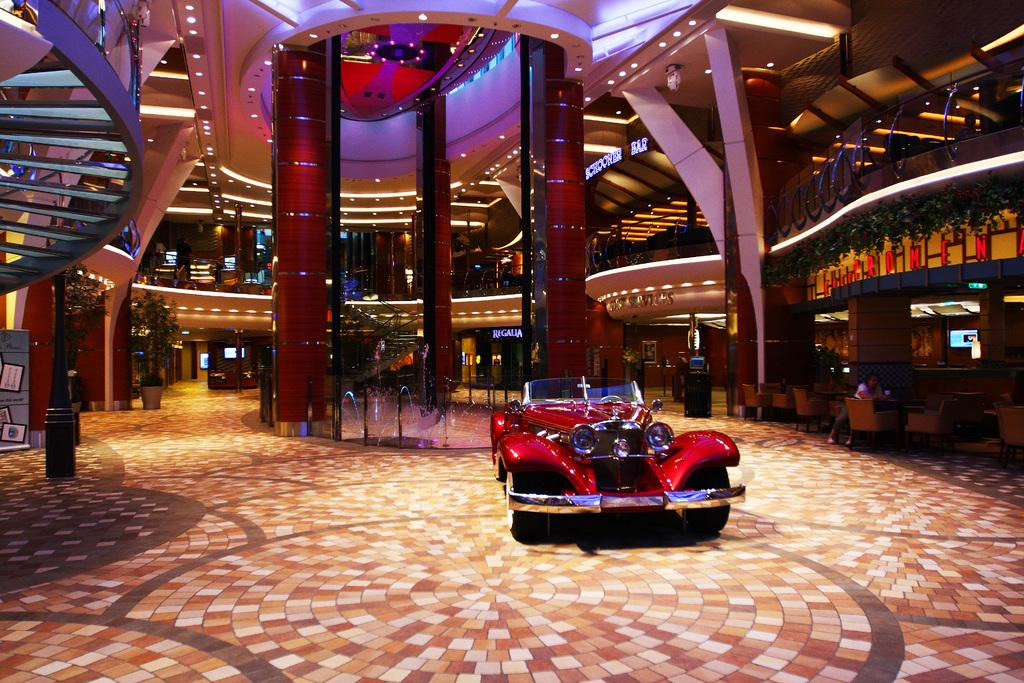What color is the car in the image? The car in the image is red. What is visible in the background of the image? There is water, a wall, and plants visible in the background of the image. What architectural features can be seen in the image? There are stairs in the image. What type of lighting is present in the image? There are lights in the image. What electronic devices are visible in the image? There are screens in the image. What type of flooring is present in the image? There are tiles in the image. Can you see a banana being peeled on the stairs in the image? No, there is no banana or any activity involving a banana in the image. 